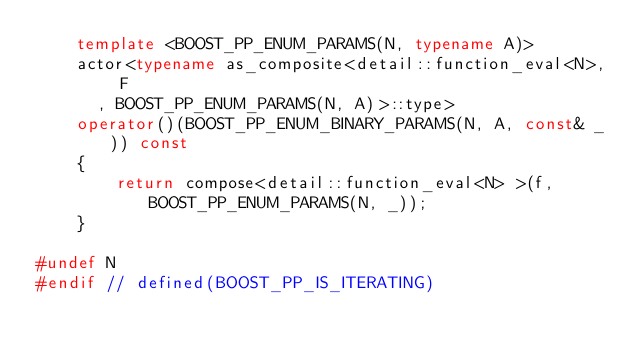<code> <loc_0><loc_0><loc_500><loc_500><_C++_>    template <BOOST_PP_ENUM_PARAMS(N, typename A)>
    actor<typename as_composite<detail::function_eval<N>, F
      , BOOST_PP_ENUM_PARAMS(N, A)>::type>
    operator()(BOOST_PP_ENUM_BINARY_PARAMS(N, A, const& _)) const
    {
        return compose<detail::function_eval<N> >(f, BOOST_PP_ENUM_PARAMS(N, _));
    }

#undef N
#endif // defined(BOOST_PP_IS_ITERATING)


</code> 